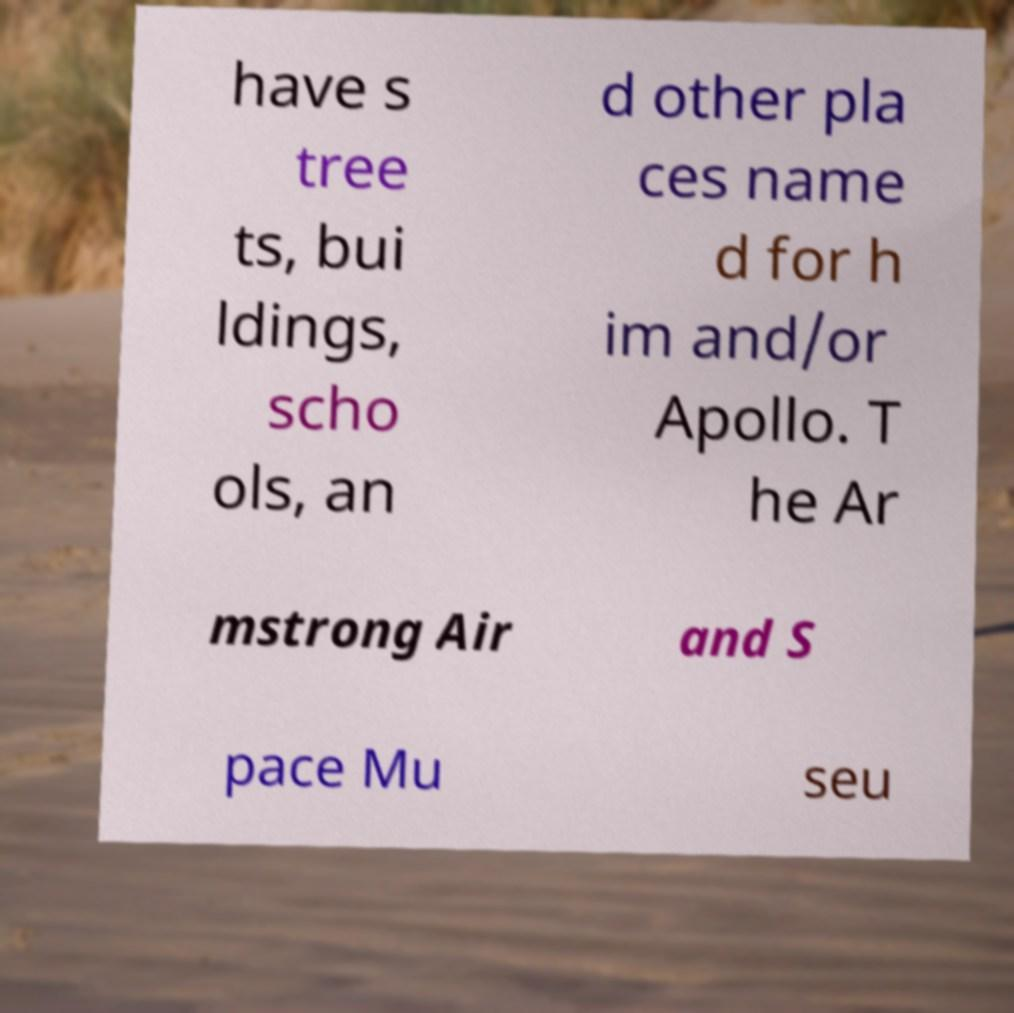What messages or text are displayed in this image? I need them in a readable, typed format. have s tree ts, bui ldings, scho ols, an d other pla ces name d for h im and/or Apollo. T he Ar mstrong Air and S pace Mu seu 